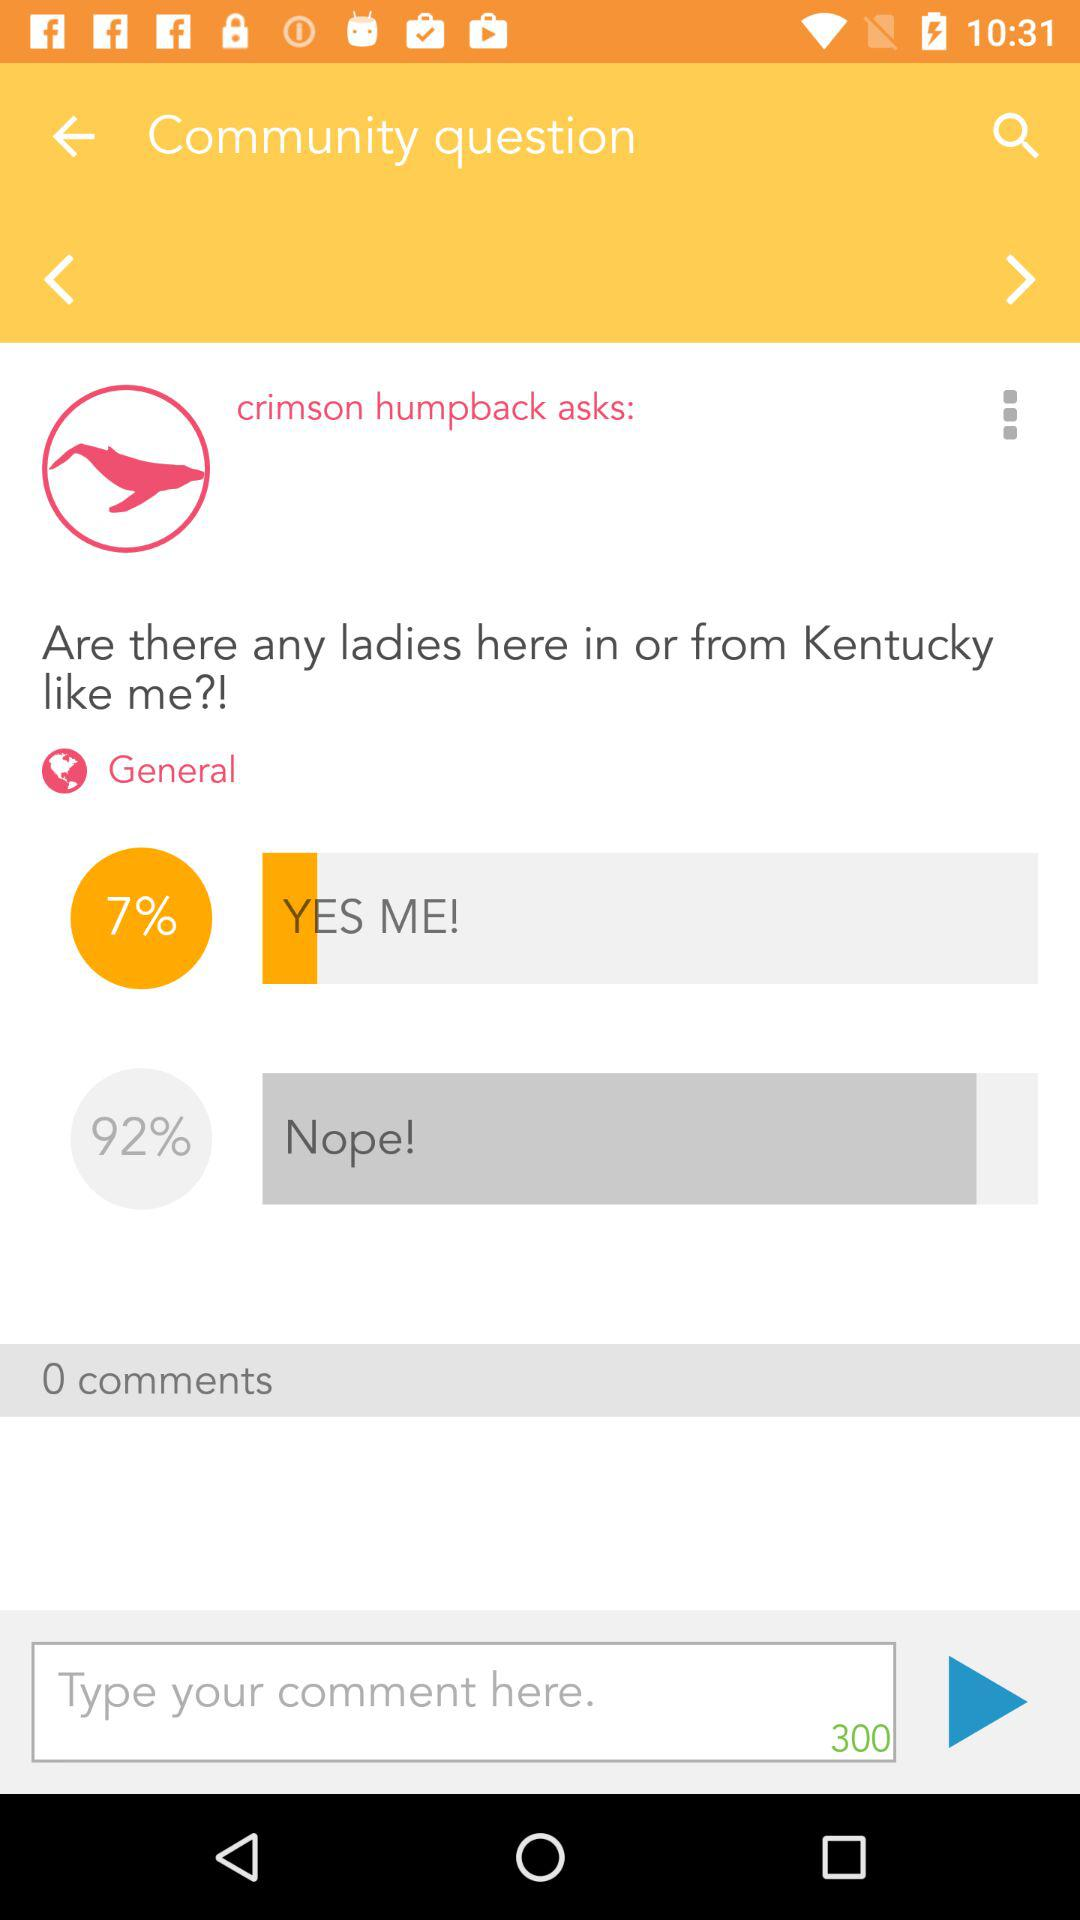How many comments are there? There are 0 comments. 